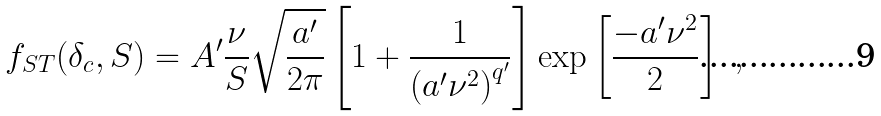Convert formula to latex. <formula><loc_0><loc_0><loc_500><loc_500>f _ { S T } ( \delta _ { c } , S ) = A ^ { \prime } \frac { \nu } { S } \sqrt { \frac { a ^ { \prime } } { 2 \pi } } \left [ 1 + \frac { 1 } { \left ( a ^ { \prime } \nu ^ { 2 } \right ) ^ { q ^ { \prime } } } \right ] \exp \left [ \frac { - a ^ { \prime } \nu ^ { 2 } } { 2 } \right ] \ ,</formula> 